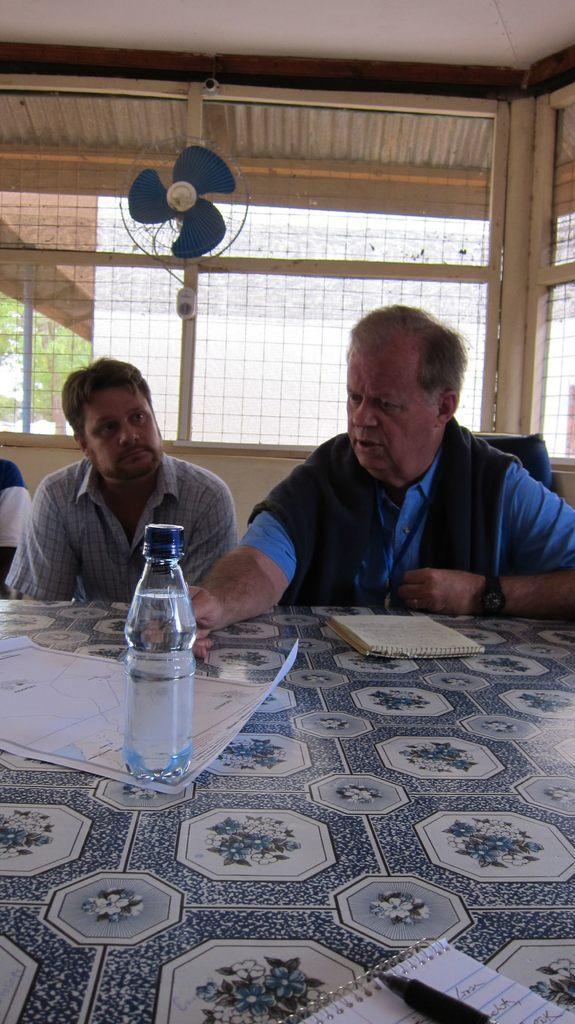How would you summarize this image in a sentence or two? There are two persons sitting in front of table behind fan on wall. 